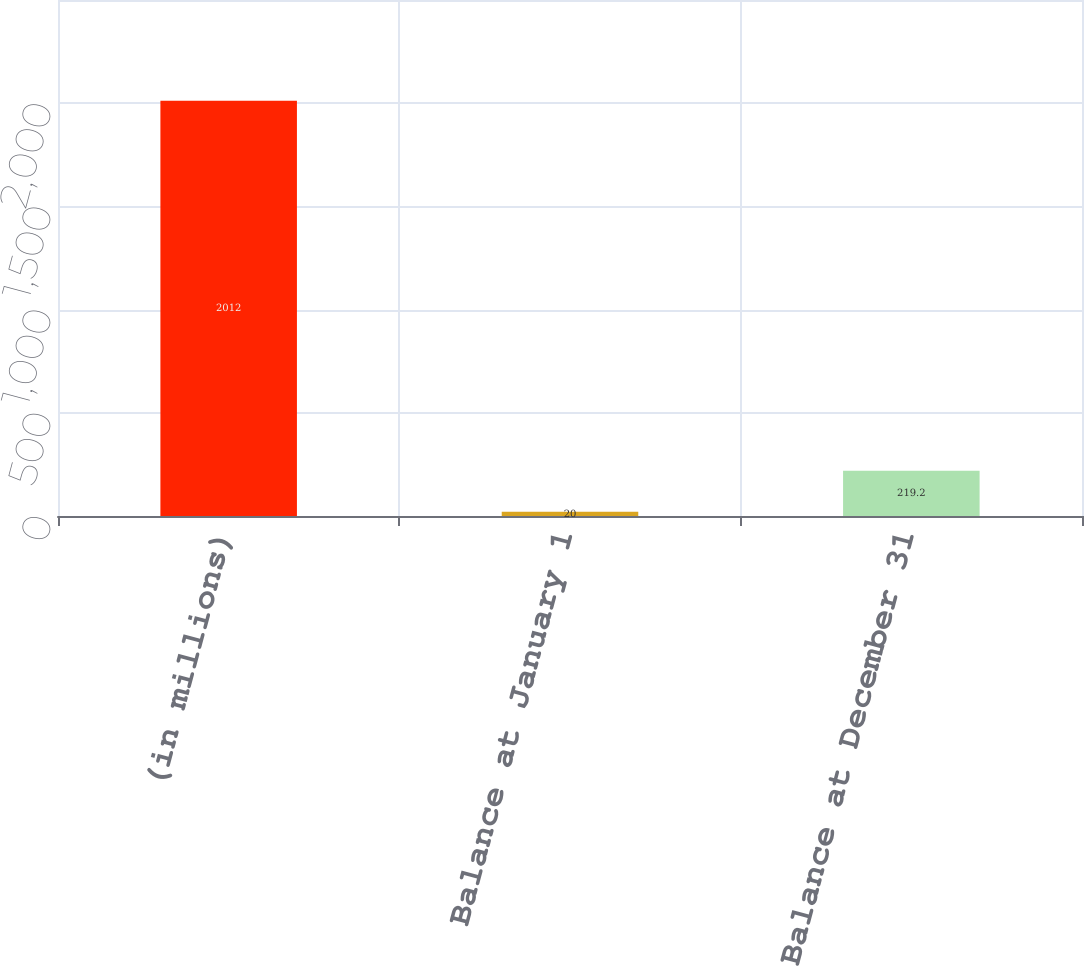Convert chart to OTSL. <chart><loc_0><loc_0><loc_500><loc_500><bar_chart><fcel>(in millions)<fcel>Balance at January 1<fcel>Balance at December 31<nl><fcel>2012<fcel>20<fcel>219.2<nl></chart> 